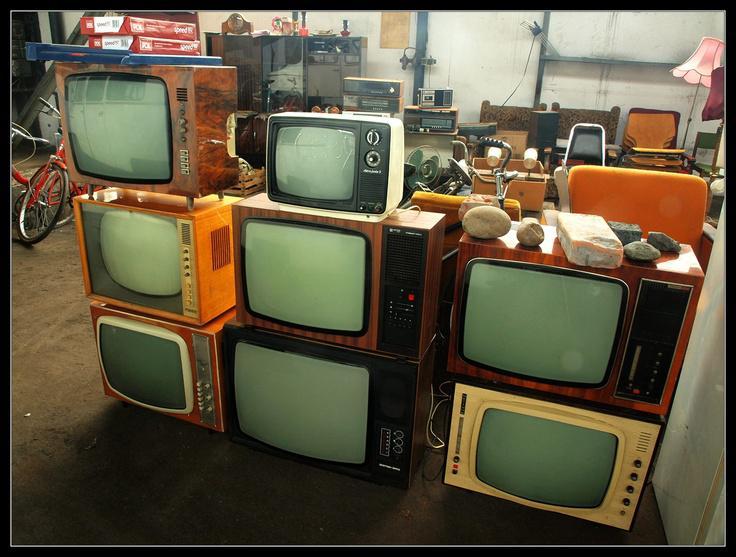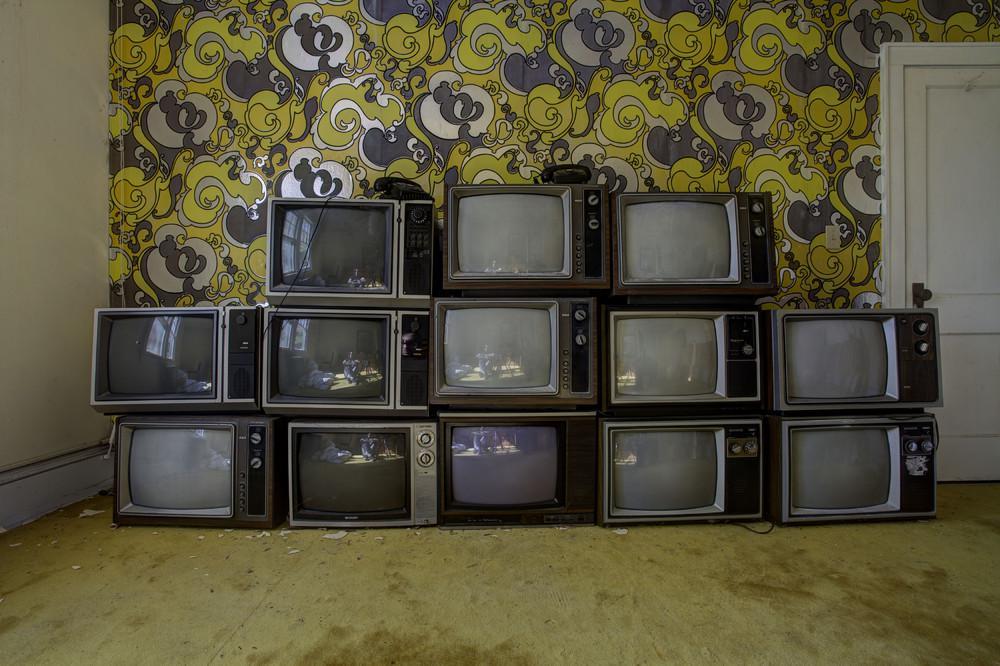The first image is the image on the left, the second image is the image on the right. Examine the images to the left and right. Is the description "Each image contains at least one stack that includes multiple different models of old-fashioned TV sets." accurate? Answer yes or no. Yes. 